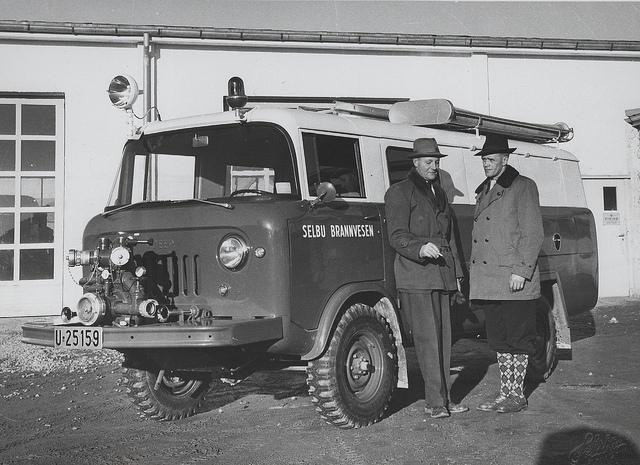Are they holding guns?
Keep it brief. No. What is the man standing on?
Answer briefly. Ground. Are these guys wearing hat?
Give a very brief answer. Yes. What type of socks is the man wearing on the right?
Keep it brief. Argyle. What is the license plate number?
Quick response, please. U-25159. How many people in the photo?
Write a very short answer. 2. 